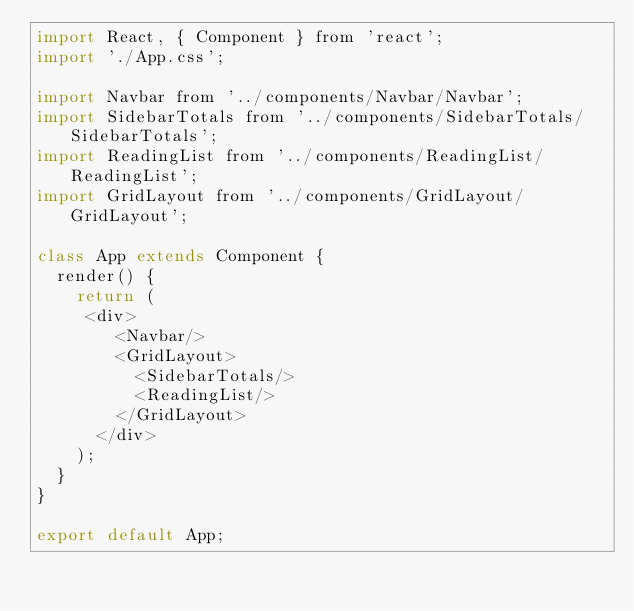<code> <loc_0><loc_0><loc_500><loc_500><_JavaScript_>import React, { Component } from 'react';
import './App.css';

import Navbar from '../components/Navbar/Navbar';
import SidebarTotals from '../components/SidebarTotals/SidebarTotals';
import ReadingList from '../components/ReadingList/ReadingList';
import GridLayout from '../components/GridLayout/GridLayout';

class App extends Component {
  render() {
    return (
     <div>
				<Navbar/>
				<GridLayout>
					<SidebarTotals/>
					<ReadingList/>						
				</GridLayout>				
			</div>
    );
  }
}

export default App;
</code> 